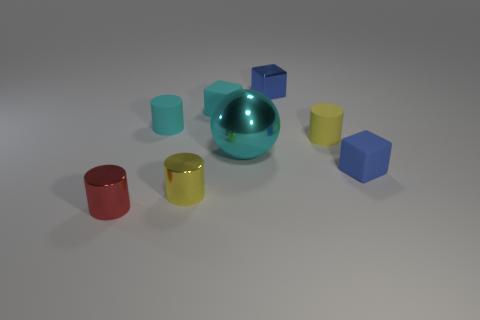Subtract all small yellow rubber cylinders. How many cylinders are left? 3 Subtract 1 cubes. How many cubes are left? 2 Add 1 shiny balls. How many objects exist? 9 Subtract all brown cylinders. Subtract all green spheres. How many cylinders are left? 4 Subtract all blocks. How many objects are left? 5 Subtract 0 green blocks. How many objects are left? 8 Subtract all metal cubes. Subtract all small blue cubes. How many objects are left? 5 Add 3 cyan matte cylinders. How many cyan matte cylinders are left? 4 Add 8 tiny cyan metal cubes. How many tiny cyan metal cubes exist? 8 